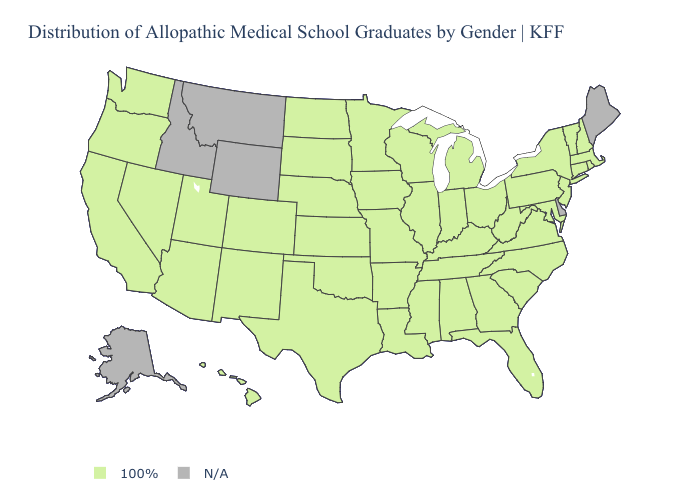Name the states that have a value in the range 100%?
Answer briefly. Alabama, Arizona, Arkansas, California, Colorado, Connecticut, Florida, Georgia, Hawaii, Illinois, Indiana, Iowa, Kansas, Kentucky, Louisiana, Maryland, Massachusetts, Michigan, Minnesota, Mississippi, Missouri, Nebraska, Nevada, New Hampshire, New Jersey, New Mexico, New York, North Carolina, North Dakota, Ohio, Oklahoma, Oregon, Pennsylvania, Rhode Island, South Carolina, South Dakota, Tennessee, Texas, Utah, Vermont, Virginia, Washington, West Virginia, Wisconsin. Name the states that have a value in the range 100%?
Short answer required. Alabama, Arizona, Arkansas, California, Colorado, Connecticut, Florida, Georgia, Hawaii, Illinois, Indiana, Iowa, Kansas, Kentucky, Louisiana, Maryland, Massachusetts, Michigan, Minnesota, Mississippi, Missouri, Nebraska, Nevada, New Hampshire, New Jersey, New Mexico, New York, North Carolina, North Dakota, Ohio, Oklahoma, Oregon, Pennsylvania, Rhode Island, South Carolina, South Dakota, Tennessee, Texas, Utah, Vermont, Virginia, Washington, West Virginia, Wisconsin. Name the states that have a value in the range 100%?
Write a very short answer. Alabama, Arizona, Arkansas, California, Colorado, Connecticut, Florida, Georgia, Hawaii, Illinois, Indiana, Iowa, Kansas, Kentucky, Louisiana, Maryland, Massachusetts, Michigan, Minnesota, Mississippi, Missouri, Nebraska, Nevada, New Hampshire, New Jersey, New Mexico, New York, North Carolina, North Dakota, Ohio, Oklahoma, Oregon, Pennsylvania, Rhode Island, South Carolina, South Dakota, Tennessee, Texas, Utah, Vermont, Virginia, Washington, West Virginia, Wisconsin. What is the value of Massachusetts?
Short answer required. 100%. What is the highest value in the USA?
Concise answer only. 100%. What is the lowest value in the MidWest?
Short answer required. 100%. Name the states that have a value in the range N/A?
Be succinct. Alaska, Delaware, Idaho, Maine, Montana, Wyoming. Name the states that have a value in the range 100%?
Answer briefly. Alabama, Arizona, Arkansas, California, Colorado, Connecticut, Florida, Georgia, Hawaii, Illinois, Indiana, Iowa, Kansas, Kentucky, Louisiana, Maryland, Massachusetts, Michigan, Minnesota, Mississippi, Missouri, Nebraska, Nevada, New Hampshire, New Jersey, New Mexico, New York, North Carolina, North Dakota, Ohio, Oklahoma, Oregon, Pennsylvania, Rhode Island, South Carolina, South Dakota, Tennessee, Texas, Utah, Vermont, Virginia, Washington, West Virginia, Wisconsin. Which states have the lowest value in the USA?
Answer briefly. Alabama, Arizona, Arkansas, California, Colorado, Connecticut, Florida, Georgia, Hawaii, Illinois, Indiana, Iowa, Kansas, Kentucky, Louisiana, Maryland, Massachusetts, Michigan, Minnesota, Mississippi, Missouri, Nebraska, Nevada, New Hampshire, New Jersey, New Mexico, New York, North Carolina, North Dakota, Ohio, Oklahoma, Oregon, Pennsylvania, Rhode Island, South Carolina, South Dakota, Tennessee, Texas, Utah, Vermont, Virginia, Washington, West Virginia, Wisconsin. What is the lowest value in the MidWest?
Write a very short answer. 100%. What is the highest value in the Northeast ?
Keep it brief. 100%. Does the first symbol in the legend represent the smallest category?
Quick response, please. No. 